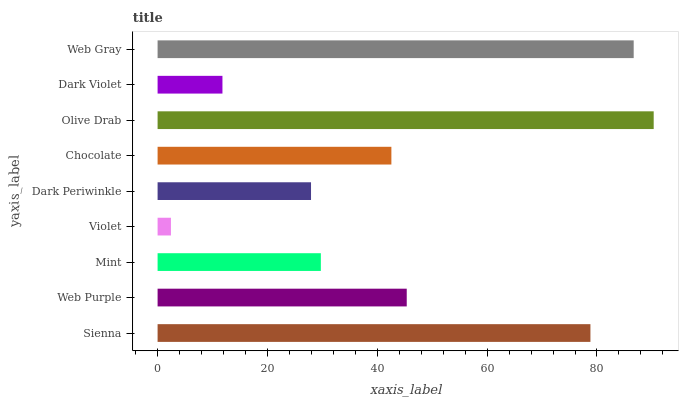Is Violet the minimum?
Answer yes or no. Yes. Is Olive Drab the maximum?
Answer yes or no. Yes. Is Web Purple the minimum?
Answer yes or no. No. Is Web Purple the maximum?
Answer yes or no. No. Is Sienna greater than Web Purple?
Answer yes or no. Yes. Is Web Purple less than Sienna?
Answer yes or no. Yes. Is Web Purple greater than Sienna?
Answer yes or no. No. Is Sienna less than Web Purple?
Answer yes or no. No. Is Chocolate the high median?
Answer yes or no. Yes. Is Chocolate the low median?
Answer yes or no. Yes. Is Mint the high median?
Answer yes or no. No. Is Web Gray the low median?
Answer yes or no. No. 